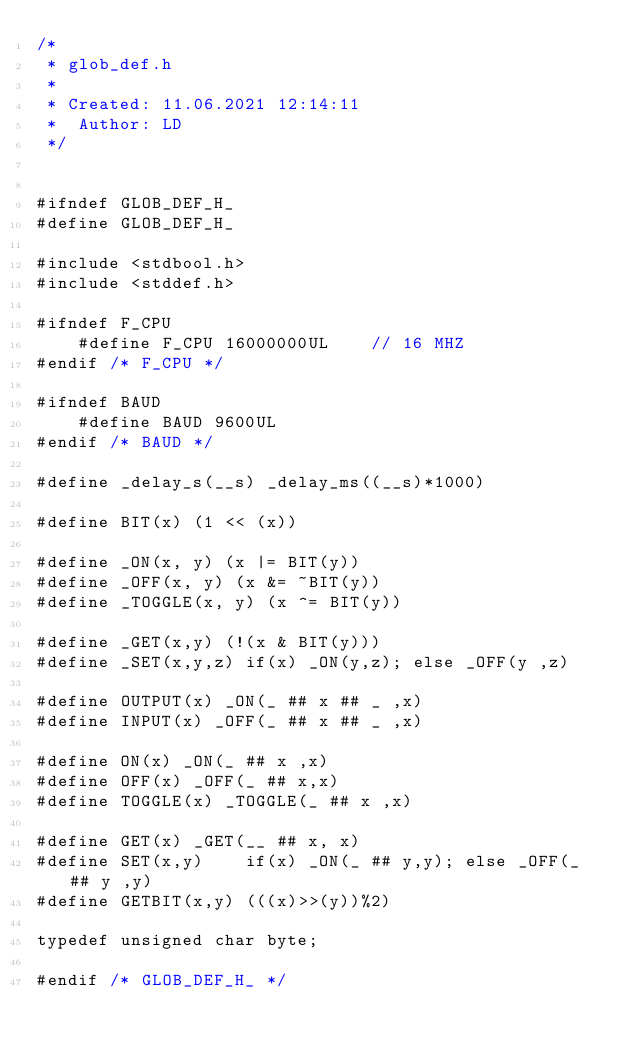<code> <loc_0><loc_0><loc_500><loc_500><_C_>/*
 * glob_def.h
 *
 * Created: 11.06.2021 12:14:11
 *  Author: LD
 */ 


#ifndef GLOB_DEF_H_
#define GLOB_DEF_H_

#include <stdbool.h>
#include <stddef.h>

#ifndef F_CPU
    #define F_CPU 16000000UL	// 16 MHZ
#endif /* F_CPU */

#ifndef	BAUD
	#define BAUD 9600UL
#endif /* BAUD */

#define _delay_s(__s) _delay_ms((__s)*1000)

#define BIT(x) (1 << (x))

#define _ON(x, y) (x |= BIT(y))
#define _OFF(x, y) (x &= ~BIT(y))
#define _TOGGLE(x, y) (x ^= BIT(y))

#define _GET(x,y) (!(x & BIT(y)))
#define _SET(x,y,z)	if(x) _ON(y,z); else _OFF(y ,z)

#define OUTPUT(x) _ON(_ ## x ## _ ,x)
#define INPUT(x) _OFF(_ ## x ## _ ,x)

#define ON(x) _ON(_ ## x ,x)
#define OFF(x) _OFF(_ ## x,x)
#define TOGGLE(x) _TOGGLE(_ ## x ,x)

#define GET(x) _GET(__ ## x, x)
#define SET(x,y)	if(x) _ON(_ ## y,y); else _OFF(_ ## y ,y)
#define GETBIT(x,y) (((x)>>(y))%2)

typedef unsigned char byte;

#endif /* GLOB_DEF_H_ */</code> 